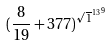<formula> <loc_0><loc_0><loc_500><loc_500>( \frac { 8 } { 1 9 } + 3 7 7 ) ^ { { \sqrt { 1 } ^ { 1 3 } } ^ { 9 } }</formula> 